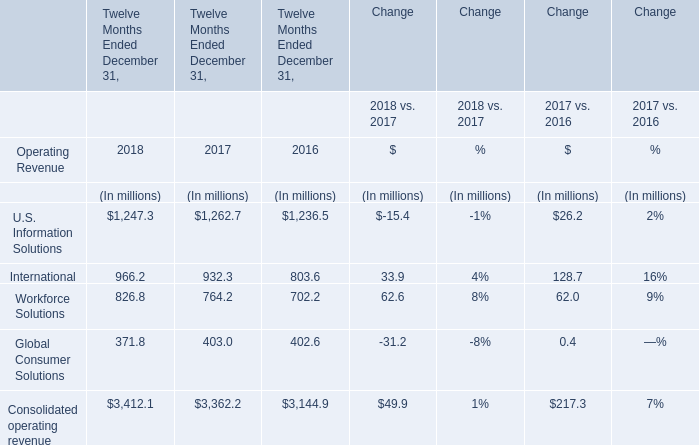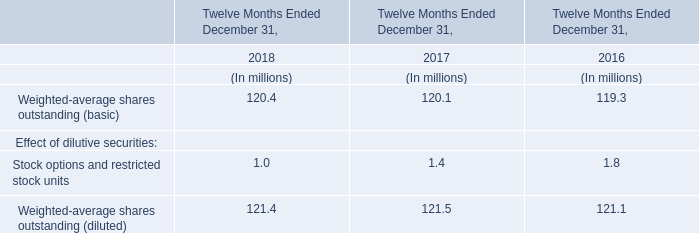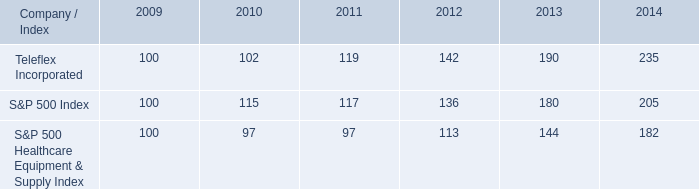What is the growing rate of International in the years with the least Global Consumer Solutions? 
Computations: ((966.2 - 932.3) / 932.3)
Answer: 0.03636. 